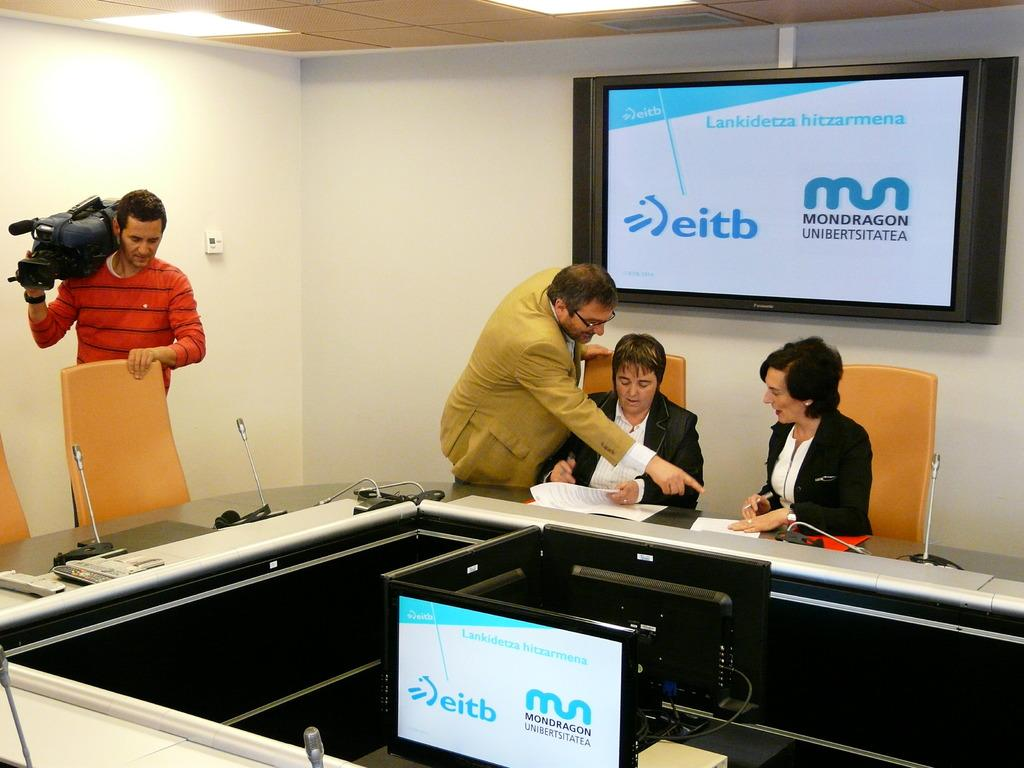<image>
Present a compact description of the photo's key features. Three people at a desk with a screen behind them that reads eitb. 